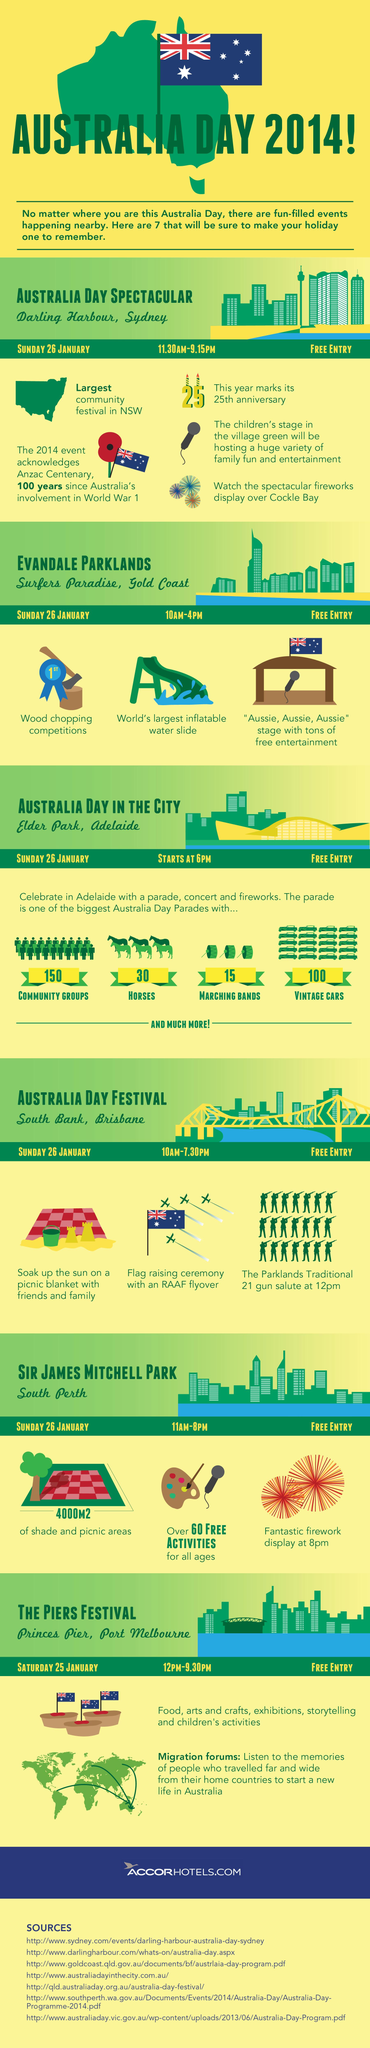Draw attention to some important aspects in this diagram. There will be 15 Marching Bands present in the Australia Day parade. The event where the traditional 21 gun salute is taking place is located at South Bank in Brisbane. On Australia Day, 30 horses participated in the parade. The Sir James Mitchell Park in South Perth has hosted three events. On Australia Day, 150 community groups will participate in the parade. 